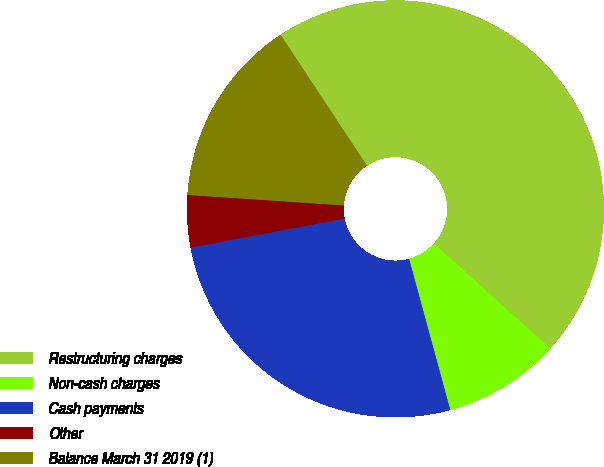<chart> <loc_0><loc_0><loc_500><loc_500><pie_chart><fcel>Restructuring charges<fcel>Non-cash charges<fcel>Cash payments<fcel>Other<fcel>Balance March 31 2019 (1)<nl><fcel>45.96%<fcel>9.09%<fcel>26.26%<fcel>4.04%<fcel>14.65%<nl></chart> 